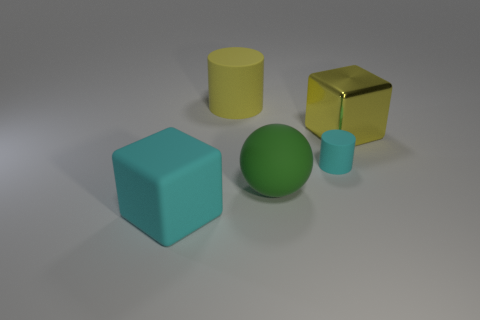Add 3 big green matte spheres. How many objects exist? 8 Subtract 1 cylinders. How many cylinders are left? 1 Subtract all gray cylinders. Subtract all gray balls. How many cylinders are left? 2 Subtract all green cylinders. How many green blocks are left? 0 Subtract all tiny cyan matte cylinders. Subtract all cylinders. How many objects are left? 2 Add 3 matte blocks. How many matte blocks are left? 4 Add 4 gray metallic balls. How many gray metallic balls exist? 4 Subtract all cyan cylinders. How many cylinders are left? 1 Subtract 1 green spheres. How many objects are left? 4 Subtract all cubes. How many objects are left? 3 